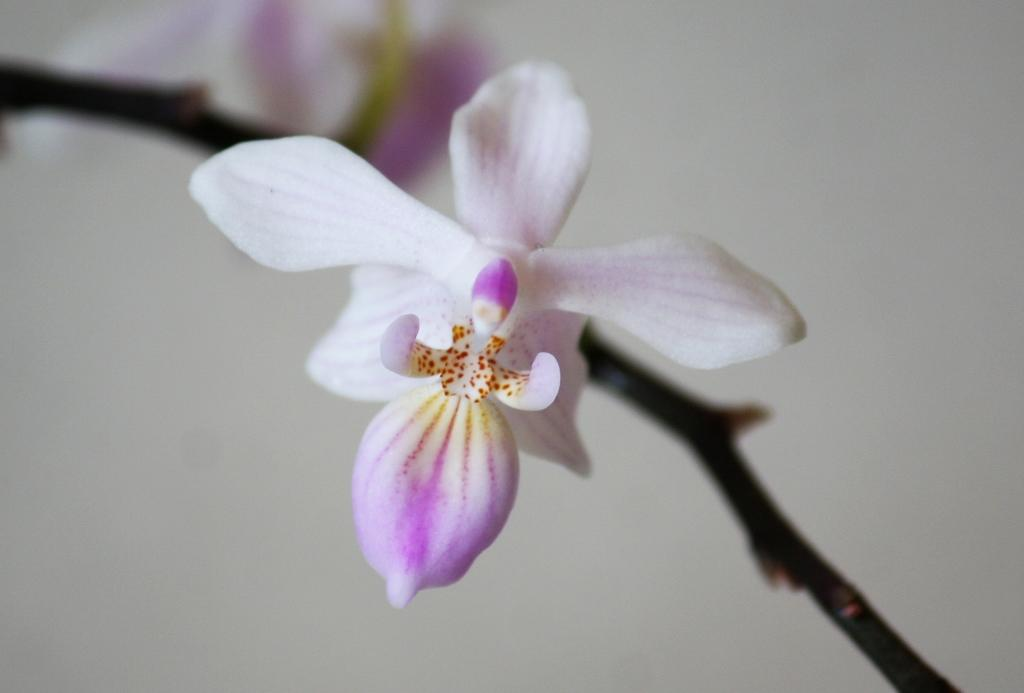What is the main subject of the image? There is a flower in the image. Can you describe any part of the flower in the image? There is a stem in the image. What type of treatment is being administered to the flower in the image? There is no treatment being administered to the flower in the image; it is simply a flower with a stem. 